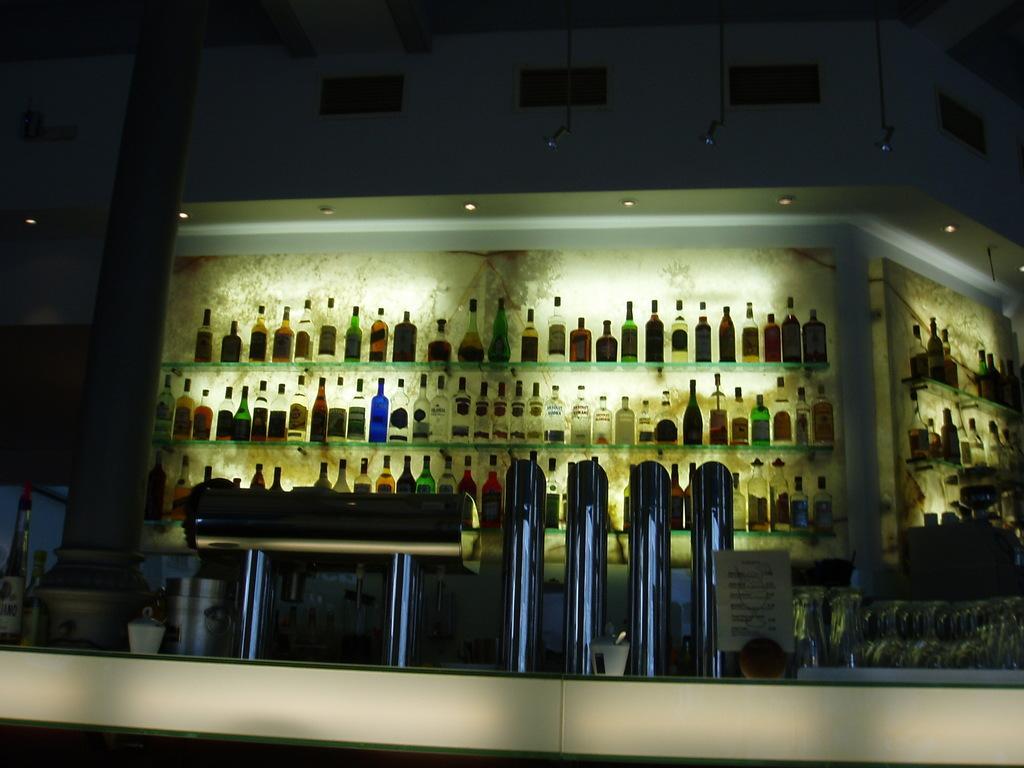How would you summarize this image in a sentence or two? This image is dark where we can see many bottles are kept on the shelf. Here we can see many glasses kept in the tray, jars and a few more bottles kept here. In the background, we can see ventilators to the wall. 